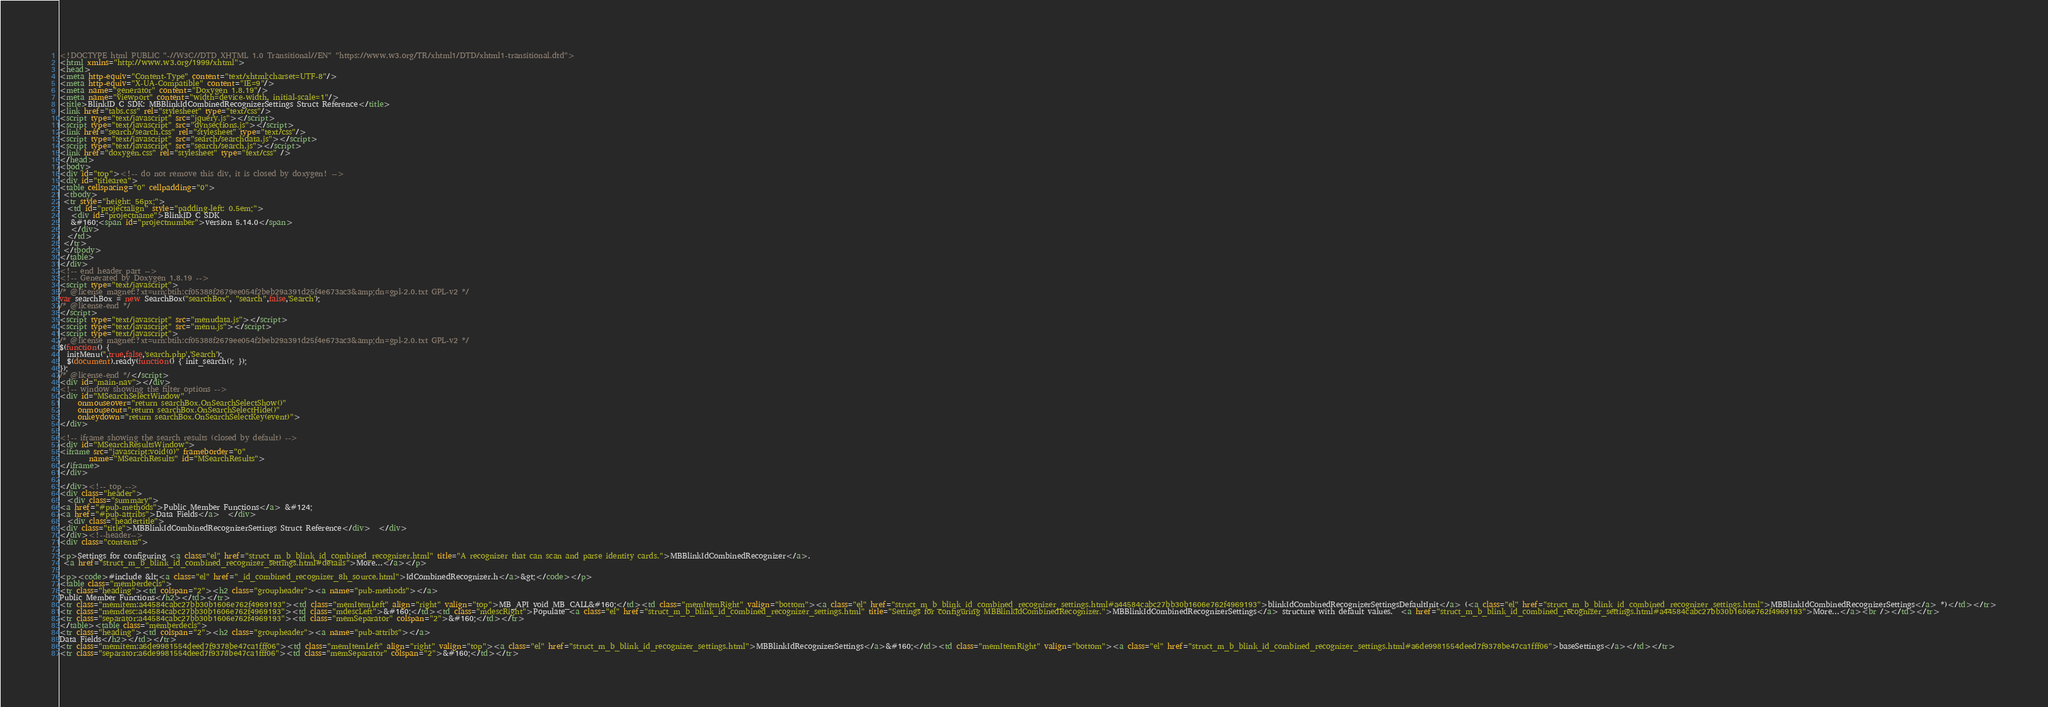Convert code to text. <code><loc_0><loc_0><loc_500><loc_500><_HTML_><!DOCTYPE html PUBLIC "-//W3C//DTD XHTML 1.0 Transitional//EN" "https://www.w3.org/TR/xhtml1/DTD/xhtml1-transitional.dtd">
<html xmlns="http://www.w3.org/1999/xhtml">
<head>
<meta http-equiv="Content-Type" content="text/xhtml;charset=UTF-8"/>
<meta http-equiv="X-UA-Compatible" content="IE=9"/>
<meta name="generator" content="Doxygen 1.8.19"/>
<meta name="viewport" content="width=device-width, initial-scale=1"/>
<title>BlinkID C SDK: MBBlinkIdCombinedRecognizerSettings Struct Reference</title>
<link href="tabs.css" rel="stylesheet" type="text/css"/>
<script type="text/javascript" src="jquery.js"></script>
<script type="text/javascript" src="dynsections.js"></script>
<link href="search/search.css" rel="stylesheet" type="text/css"/>
<script type="text/javascript" src="search/searchdata.js"></script>
<script type="text/javascript" src="search/search.js"></script>
<link href="doxygen.css" rel="stylesheet" type="text/css" />
</head>
<body>
<div id="top"><!-- do not remove this div, it is closed by doxygen! -->
<div id="titlearea">
<table cellspacing="0" cellpadding="0">
 <tbody>
 <tr style="height: 56px;">
  <td id="projectalign" style="padding-left: 0.5em;">
   <div id="projectname">BlinkID C SDK
   &#160;<span id="projectnumber">version 5.14.0</span>
   </div>
  </td>
 </tr>
 </tbody>
</table>
</div>
<!-- end header part -->
<!-- Generated by Doxygen 1.8.19 -->
<script type="text/javascript">
/* @license magnet:?xt=urn:btih:cf05388f2679ee054f2beb29a391d25f4e673ac3&amp;dn=gpl-2.0.txt GPL-v2 */
var searchBox = new SearchBox("searchBox", "search",false,'Search');
/* @license-end */
</script>
<script type="text/javascript" src="menudata.js"></script>
<script type="text/javascript" src="menu.js"></script>
<script type="text/javascript">
/* @license magnet:?xt=urn:btih:cf05388f2679ee054f2beb29a391d25f4e673ac3&amp;dn=gpl-2.0.txt GPL-v2 */
$(function() {
  initMenu('',true,false,'search.php','Search');
  $(document).ready(function() { init_search(); });
});
/* @license-end */</script>
<div id="main-nav"></div>
<!-- window showing the filter options -->
<div id="MSearchSelectWindow"
     onmouseover="return searchBox.OnSearchSelectShow()"
     onmouseout="return searchBox.OnSearchSelectHide()"
     onkeydown="return searchBox.OnSearchSelectKey(event)">
</div>

<!-- iframe showing the search results (closed by default) -->
<div id="MSearchResultsWindow">
<iframe src="javascript:void(0)" frameborder="0" 
        name="MSearchResults" id="MSearchResults">
</iframe>
</div>

</div><!-- top -->
<div class="header">
  <div class="summary">
<a href="#pub-methods">Public Member Functions</a> &#124;
<a href="#pub-attribs">Data Fields</a>  </div>
  <div class="headertitle">
<div class="title">MBBlinkIdCombinedRecognizerSettings Struct Reference</div>  </div>
</div><!--header-->
<div class="contents">

<p>Settings for configuring <a class="el" href="struct_m_b_blink_id_combined_recognizer.html" title="A recognizer that can scan and parse identity cards.">MBBlinkIdCombinedRecognizer</a>.  
 <a href="struct_m_b_blink_id_combined_recognizer_settings.html#details">More...</a></p>

<p><code>#include &lt;<a class="el" href="_id_combined_recognizer_8h_source.html">IdCombinedRecognizer.h</a>&gt;</code></p>
<table class="memberdecls">
<tr class="heading"><td colspan="2"><h2 class="groupheader"><a name="pub-methods"></a>
Public Member Functions</h2></td></tr>
<tr class="memitem:a44584cabc27bb30b1606e762f4969193"><td class="memItemLeft" align="right" valign="top">MB_API void MB_CALL&#160;</td><td class="memItemRight" valign="bottom"><a class="el" href="struct_m_b_blink_id_combined_recognizer_settings.html#a44584cabc27bb30b1606e762f4969193">blinkIdCombinedRecognizerSettingsDefaultInit</a> (<a class="el" href="struct_m_b_blink_id_combined_recognizer_settings.html">MBBlinkIdCombinedRecognizerSettings</a> *)</td></tr>
<tr class="memdesc:a44584cabc27bb30b1606e762f4969193"><td class="mdescLeft">&#160;</td><td class="mdescRight">Populate <a class="el" href="struct_m_b_blink_id_combined_recognizer_settings.html" title="Settings for configuring MBBlinkIdCombinedRecognizer.">MBBlinkIdCombinedRecognizerSettings</a> structure with default values.  <a href="struct_m_b_blink_id_combined_recognizer_settings.html#a44584cabc27bb30b1606e762f4969193">More...</a><br /></td></tr>
<tr class="separator:a44584cabc27bb30b1606e762f4969193"><td class="memSeparator" colspan="2">&#160;</td></tr>
</table><table class="memberdecls">
<tr class="heading"><td colspan="2"><h2 class="groupheader"><a name="pub-attribs"></a>
Data Fields</h2></td></tr>
<tr class="memitem:a6de9981554deed7f9378be47ca1fff06"><td class="memItemLeft" align="right" valign="top"><a class="el" href="struct_m_b_blink_id_recognizer_settings.html">MBBlinkIdRecognizerSettings</a>&#160;</td><td class="memItemRight" valign="bottom"><a class="el" href="struct_m_b_blink_id_combined_recognizer_settings.html#a6de9981554deed7f9378be47ca1fff06">baseSettings</a></td></tr>
<tr class="separator:a6de9981554deed7f9378be47ca1fff06"><td class="memSeparator" colspan="2">&#160;</td></tr></code> 